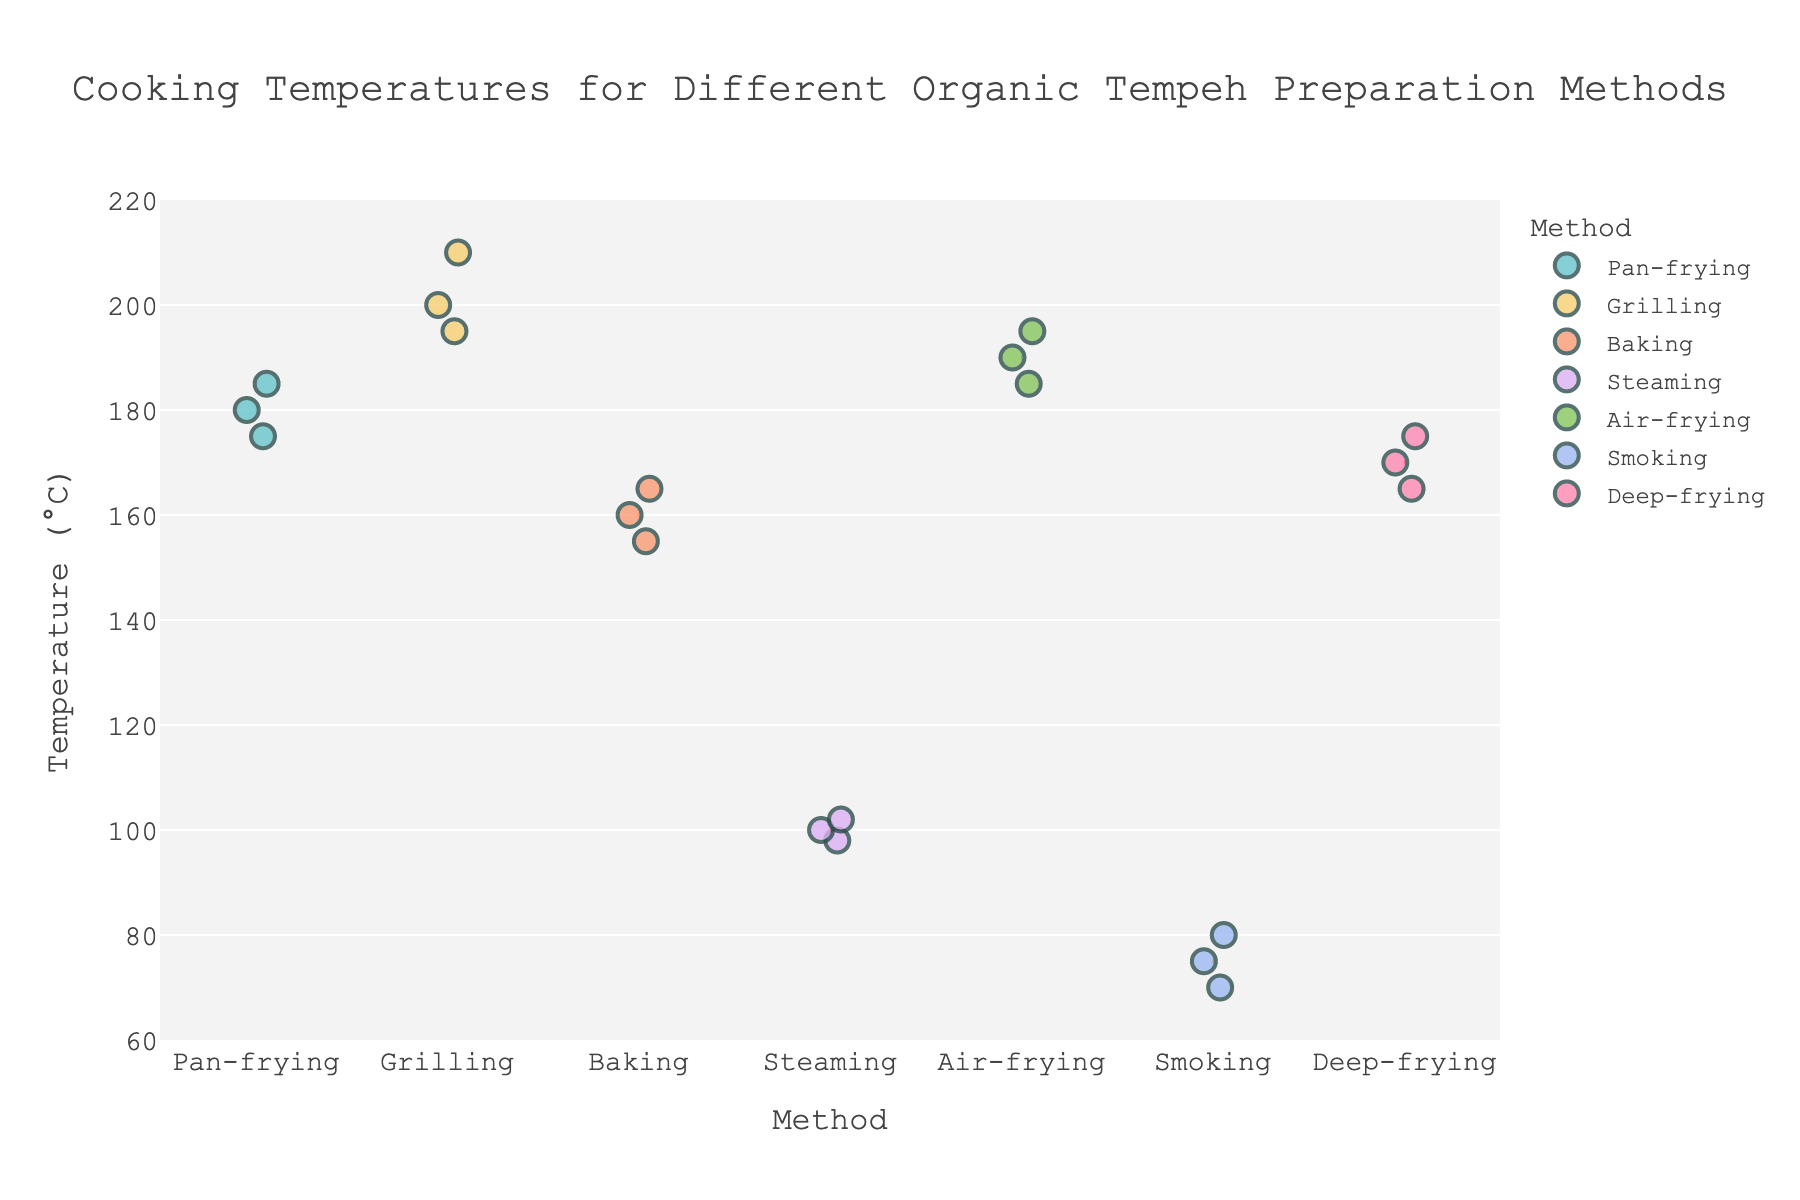What is the title of the plot? The title of the plot is found at the top of the figure and provides a quick summary of what the data represents. In this case, it indicates the plot is about cooking temperatures for different organic tempeh preparation methods.
Answer: Cooking Temperatures for Different Organic Tempeh Preparation Methods Which tempeh preparation method has the highest individual temperature? Look for the highest temperature point among all the methods on the y-axis.
Answer: Grilling What is the range of temperatures used for the Baking method? Identify the minimum and maximum temperatures for the Baking method by looking at the position of the data points on the y-axis. Baking has temperatures at 155°C, 160°C, and 165°C.
Answer: 155°C to 165°C How many data points are there for the Air-frying method? Count the number of data points (dots) that correspond to the Air-frying method on the x-axis. Each dot represents one temperature measurement.
Answer: 3 What is the average temperature used for the Steaming method? Calculate the average by summing the temperatures for Steaming (100 + 98 + 102) and dividing by the number of data points, which is 3. Average = (100 + 98 + 102) / 3.
Answer: 100°C Which method has the lowest average temperature? Compare the average temperatures of all methods (computed in individual steps) and find the lowest. It's helpful to note that the average temperature for Smoking is added as a reference line.
Answer: Smoking Compare the temperature range for Pan-frying and Deep-frying methods. Which one has a wider range? Identify the minimum and maximum temperatures for both methods: Pan-frying (175°C to 185°C) and Deep-frying (165°C to 175°C). Then find the range by subtracting the minimum from the maximum for both methods and compare them.
Answer: Pan-frying Is there any preparation method with all temperature measurements below 200°C? Check each method and see if all data points fall below 200°C. Methods like Smoking, Steaming, Deep-frying, Pan-frying, and Baking all have measurements below 200°C.
Answer: Yes Between Grilling and Air-frying, which method tends to use higher cooking temperatures? Compare the distribution of temperatures on the y-axis for both methods. The Grilling method generally has higher values compared to Air-frying.
Answer: Grilling Are there any two methods that have at least one same temperature point? Look for any overlapping data points. Both Pan-frying and Air-frying have a temperature measurement at 185°C.
Answer: Yes 